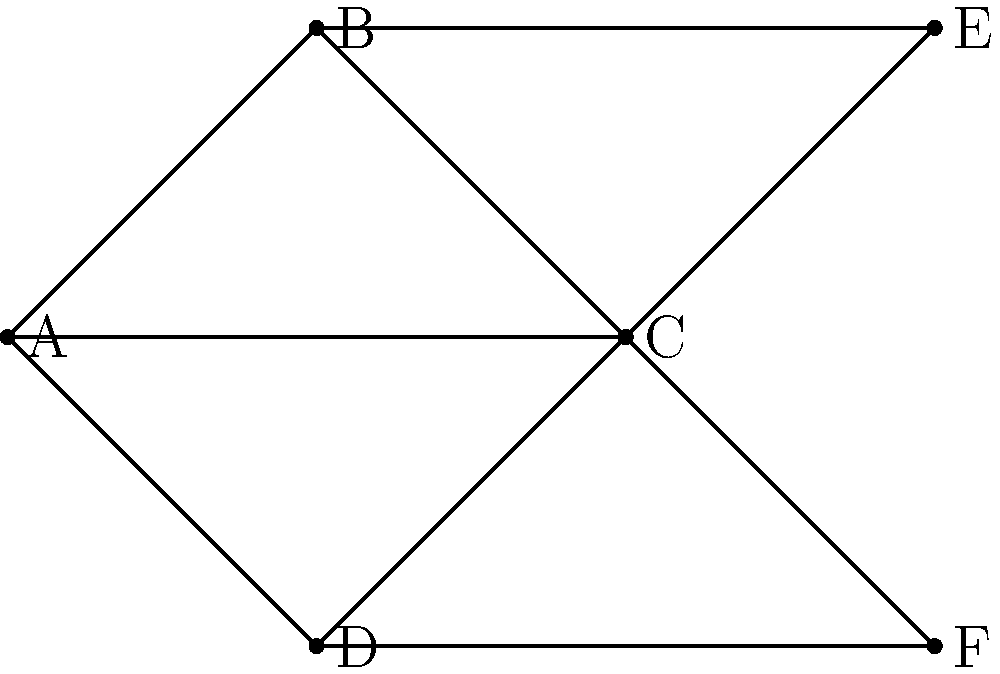As a software executive, you're analyzing the collaboration network of your development team. The graph represents team members (nodes) and their collaborations (edges). To improve team efficiency, you want to identify the most central team member who can act as a communication hub. Which node has the highest degree centrality, and what is its degree? To solve this problem, we need to follow these steps:

1. Understand degree centrality: In graph theory, degree centrality is a measure of a node's importance based on the number of edges connected to it.

2. Count the edges for each node:
   - Node A: 3 edges
   - Node B: 3 edges
   - Node C: 5 edges
   - Node D: 3 edges
   - Node E: 2 edges
   - Node F: 2 edges

3. Identify the node with the highest degree:
   Node C has the highest degree with 5 connections.

4. Interpret the result:
   In the context of team collaboration, node C represents the team member who collaborates with the most people. This person is likely to be a key player in information flow and project coordination.

5. Consider the implications:
   As a software executive, you might want to leverage this team member's central position to improve communication and collaboration across the team. However, you should also be aware of potential bottlenecks and consider ways to distribute workload and communication channels more evenly.
Answer: Node C, degree 5 